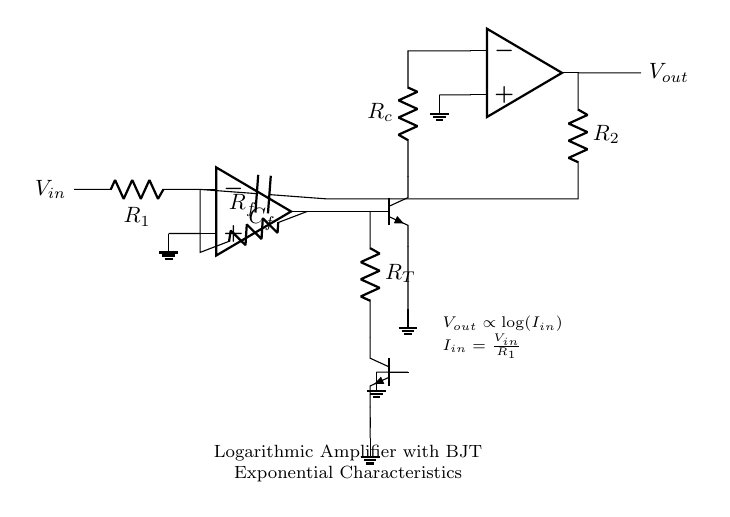What is the primary function of this circuit? The primary function of this circuit is to perform logarithmic amplification, utilizing the exponential current-voltage characteristics of bipolar junction transistors. This enables the circuit to compress a wide range of input signals into a more manageable output range that is logarithmically proportional to the input current.
Answer: Logarithmic amplification What type of transistors are used in the circuit? The circuit employs bipolar junction transistors, specifically NPN transistors, which are highlighted in the schematic. They are utilized for their exponential response to input current when configured in the logarithmic amplifier.
Answer: NPN What does the output voltage represent in relation to the input current? The output voltage represents a logarithmic function of the input current, which can be expressed as Vout proportional to log(Iin). This relationship is established by the logarithmic amplifier's design and the characteristics of the BJT.
Answer: Vout ∝ log(Iin) Which resistors are involved in the feedback loop of the circuit? The resistors involved in the feedback loop include Rf and R2, which connect back to the inverting input of the first operational amplifier and the second operational amplifier, respectively, facilitating the feedback necessary for logarithmic operation.
Answer: Rf, R2 What is the purpose of the temperature compensation in the circuit? The temperature compensation, provided by resistor R_T and the additional NPN transistor Q2, aims to maintain the performance of the logarithmic amplifier across varying temperature conditions, thereby ensuring stable operation and accurate logarithmic output even as temperature affects the characteristics of the BJTs.
Answer: Maintain performance across temperature variations What is the relationship between the input voltage and input current in this circuit? The relationship between the input voltage and input current is defined by Ohm's law, where Iin equals Vin divided by R1, illustrating that the input current increases as the input voltage increases, regulated by the value of resistor R1.
Answer: Iin = Vin / R1 